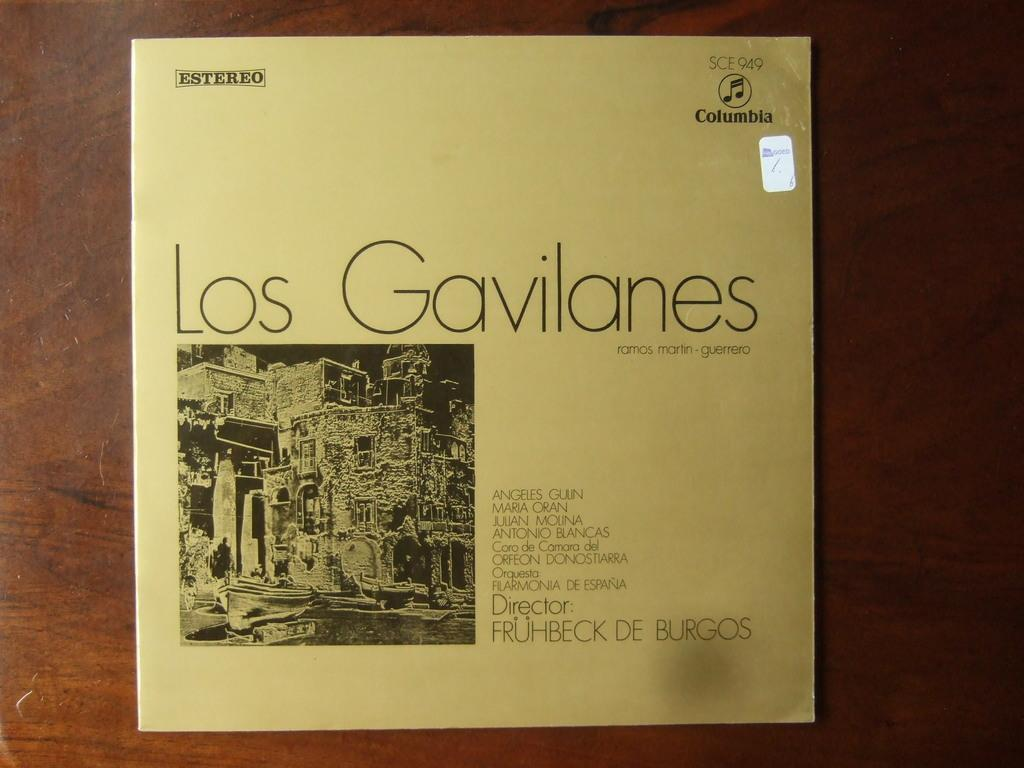<image>
Share a concise interpretation of the image provided. An off white record album cover for Los Gavilanes. 